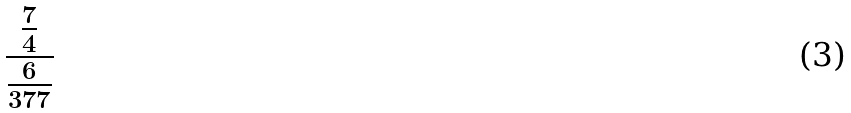<formula> <loc_0><loc_0><loc_500><loc_500>\frac { \frac { 7 } { 4 } } { \frac { 6 } { 3 7 7 } }</formula> 